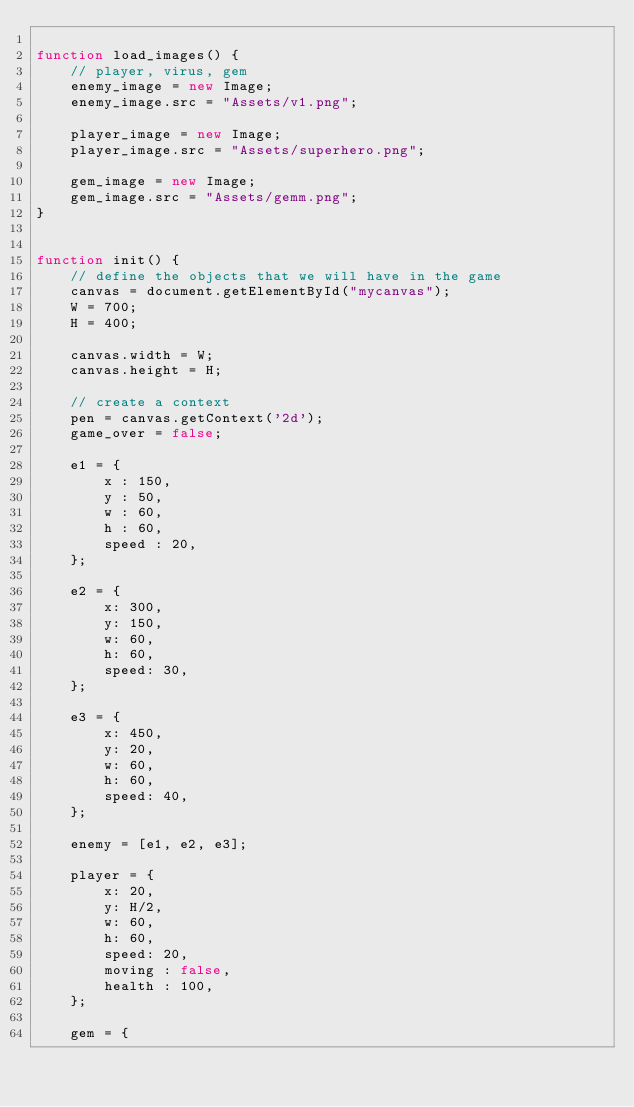Convert code to text. <code><loc_0><loc_0><loc_500><loc_500><_JavaScript_>
function load_images() {
    // player, virus, gem
    enemy_image = new Image;
    enemy_image.src = "Assets/v1.png";

    player_image = new Image;
    player_image.src = "Assets/superhero.png";

    gem_image = new Image;
    gem_image.src = "Assets/gemm.png";
}


function init() {
    // define the objects that we will have in the game
    canvas = document.getElementById("mycanvas");
    W = 700;
    H = 400;

    canvas.width = W;
    canvas.height = H;

    // create a context
    pen = canvas.getContext('2d');
    game_over = false;

    e1 = {
        x : 150,
        y : 50,
        w : 60,
        h : 60,
        speed : 20,
    };

    e2 = {
        x: 300,
        y: 150,
        w: 60,
        h: 60,
        speed: 30,
    };

    e3 = {
        x: 450,
        y: 20,
        w: 60,
        h: 60,
        speed: 40,
    };

    enemy = [e1, e2, e3];

    player = {
        x: 20,
        y: H/2,
        w: 60,
        h: 60,
        speed: 20,
        moving : false,
        health : 100,
    };

    gem = {</code> 